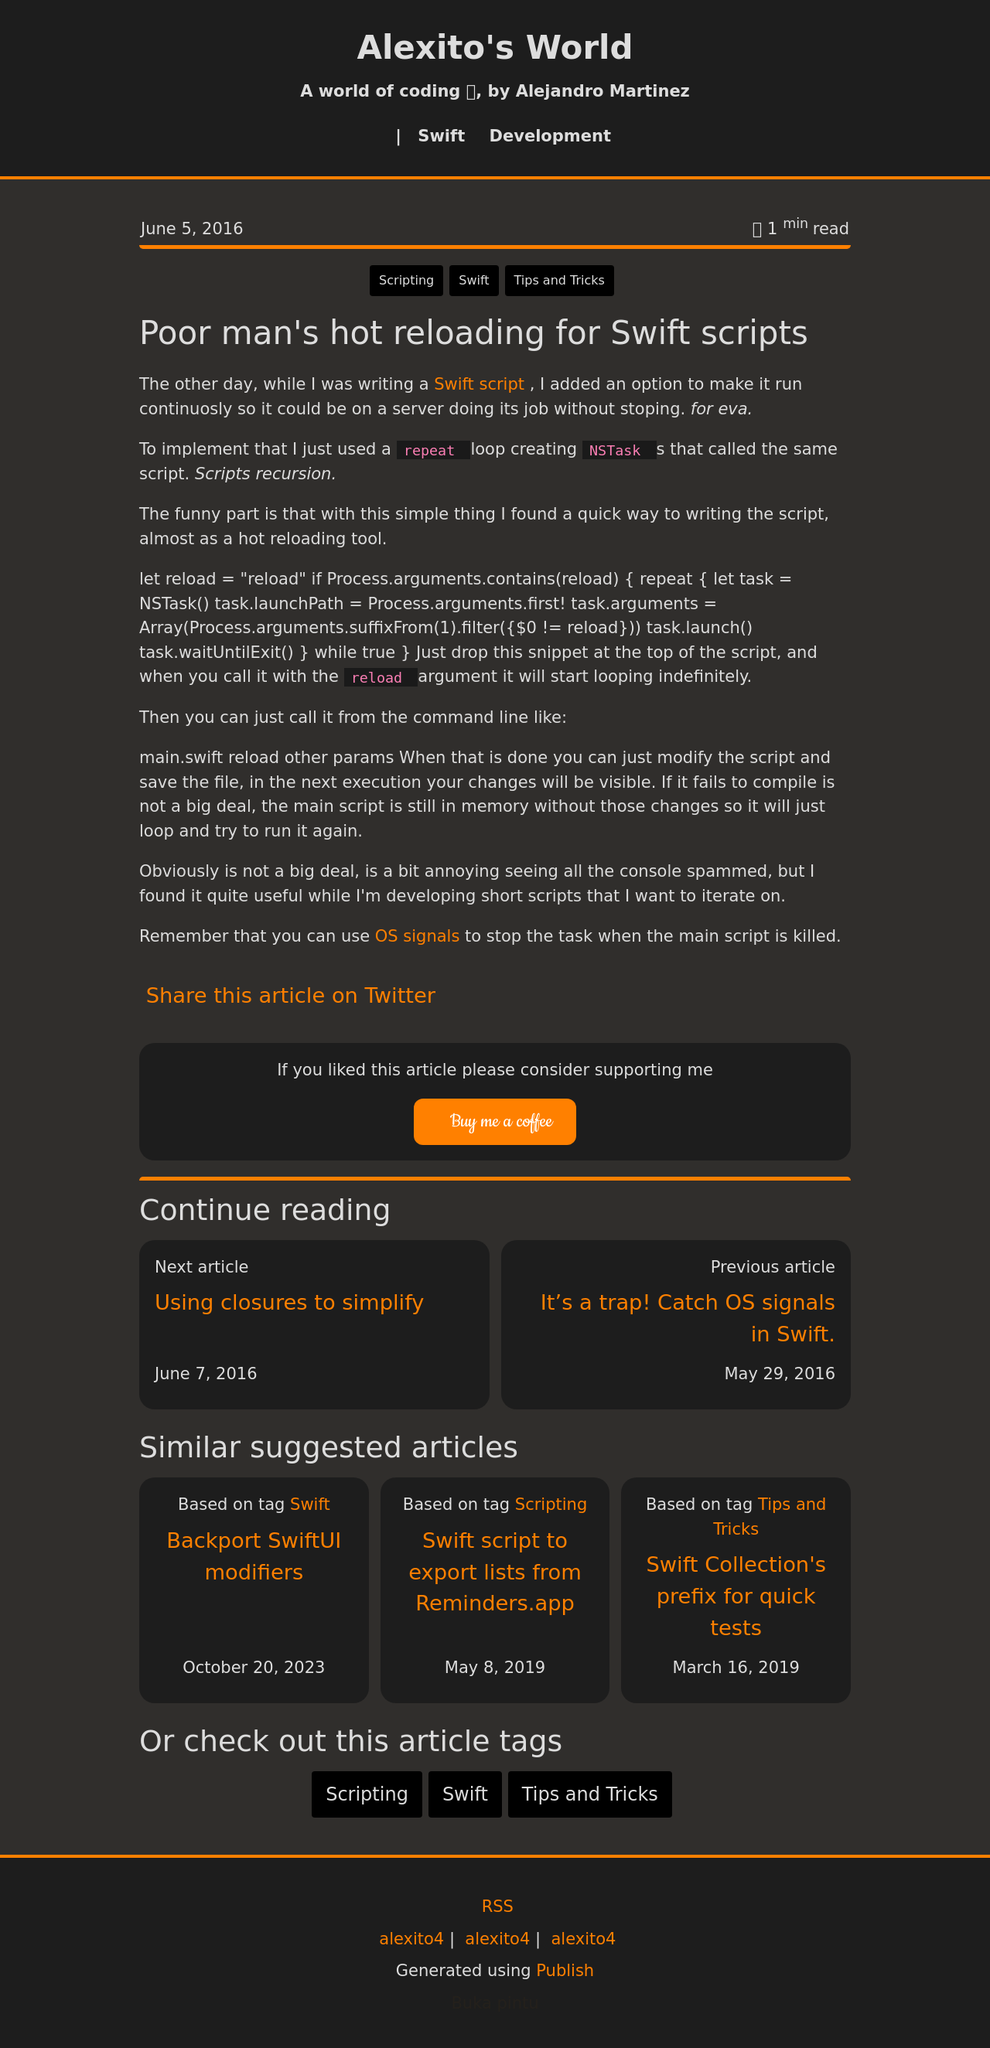Could you detail the process for assembling this website using HTML? To create a website similar to the one shown in the image, you would start by setting up the basic HTML structure including the DOCTYPE declaration, html, head, and body tags. Inside the head, include meta tags for character set, viewport settings, and SEO optimizations alongside the title tag. The body of the HTML would then include structural elements like header, nav, main, and footer tags which contain further nested elements like divs, a tags for navigation, and p tags for text content. CSS can be used to style the website according to the dark mode theme seen in the image, paying special attention to typography, spacing, and responsive design features to align with modern web standards. Javascript could be added for dynamic elements such as interactive lists or live content updates. 